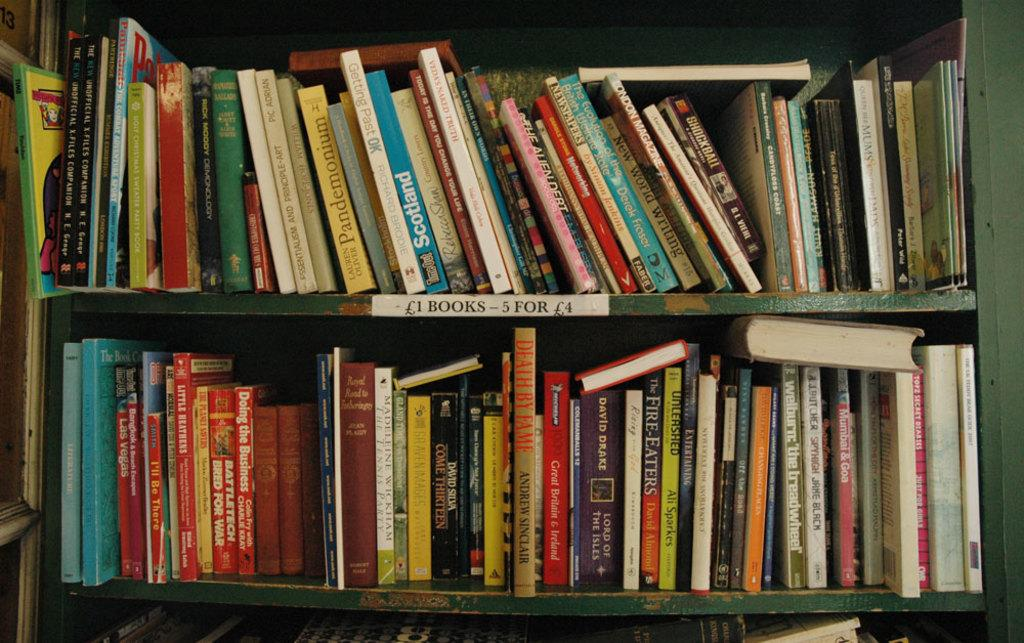<image>
Relay a brief, clear account of the picture shown. Varieties of used books are for sale for 1£ a book for 4£ for 5 books. 